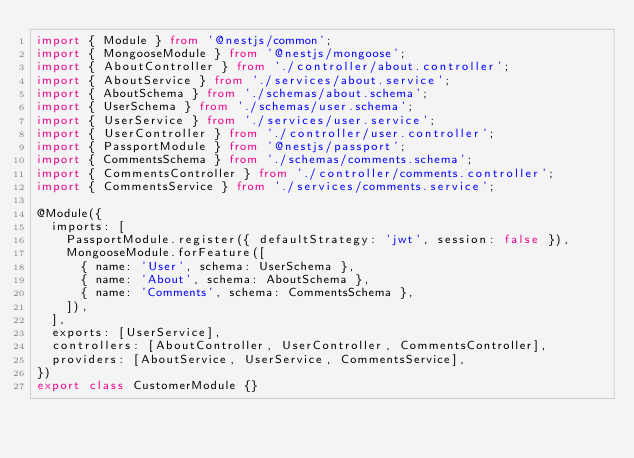Convert code to text. <code><loc_0><loc_0><loc_500><loc_500><_TypeScript_>import { Module } from '@nestjs/common';
import { MongooseModule } from '@nestjs/mongoose';
import { AboutController } from './controller/about.controller';
import { AboutService } from './services/about.service';
import { AboutSchema } from './schemas/about.schema';
import { UserSchema } from './schemas/user.schema';
import { UserService } from './services/user.service';
import { UserController } from './controller/user.controller';
import { PassportModule } from '@nestjs/passport';
import { CommentsSchema } from './schemas/comments.schema';
import { CommentsController } from './controller/comments.controller';
import { CommentsService } from './services/comments.service';

@Module({
  imports: [
    PassportModule.register({ defaultStrategy: 'jwt', session: false }),
    MongooseModule.forFeature([
      { name: 'User', schema: UserSchema },
      { name: 'About', schema: AboutSchema },
      { name: 'Comments', schema: CommentsSchema },
    ]),
  ],
  exports: [UserService],
  controllers: [AboutController, UserController, CommentsController],
  providers: [AboutService, UserService, CommentsService],
})
export class CustomerModule {}
</code> 